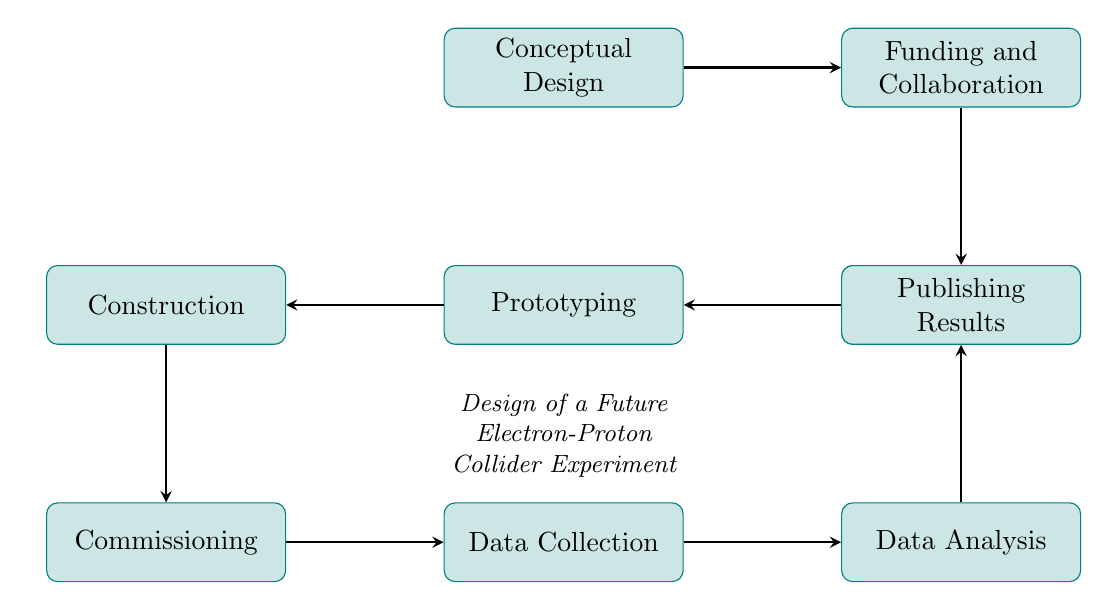What is the first step in the diagram? The first node in the flow chart is "Conceptual Design", indicating it is the starting point of the electron-proton collider experiment process.
Answer: Conceptual Design How many nodes are there in the diagram? By counting each distinct process listed as nodes in the flow chart, there are a total of nine nodes representing different stages of the experiment design.
Answer: Nine What does the "Technical Design" node lead to? The "Technical Design" node has a direct arrow pointing to the "Prototyping" node, showing that the completion of the technical design leads to prototyping.
Answer: Prototyping Which two nodes are directly connected by an arrow after "Construction"? After "Construction", there is an arrow leading to the "Commissioning" node, indicating the flow of the process from construction to commissioning.
Answer: Commissioning What is the last node in the flow chart? The final step in the flow chart is "Publishing Results", making it the last process in the sequence of tasks for the experiment.
Answer: Publishing Results What is the relationship between "Data Collection" and "Data Analysis"? "Data Collection" leads to "Data Analysis", which means that data must be collected first before it can be analyzed.
Answer: Data Collection leads to Data Analysis How are funding and collaboration related in the diagram? "Funding and Collaboration" follows directly after "Conceptual Design", highlighting the dependence of the funding phase on the conceptual groundwork of the project.
Answer: Dependent relationship What step follows after "Commissioning"? The stage that follows "Commissioning" according to the flow chart is "Data Collection", indicating that commissioning paves the way for data gathering in the experiment.
Answer: Data Collection 